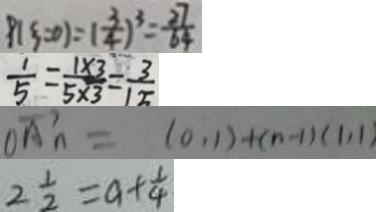<formula> <loc_0><loc_0><loc_500><loc_500>p ( \xi = 0 ) = ( \frac { 3 } { 4 } ) ^ { 3 } = \frac { 2 7 } { 6 4 } 
 \frac { 1 } { 5 } = \frac { 1 \times 3 } { 5 \times 3 } = \frac { 3 } { 1 5 } 
 \xrightarrow [ o A n ] = ( 0 , 1 ) + ( n - 1 ) ( 1 , 1 ) 
 2 \frac { 1 } { 2 } = a + \frac { 1 } { 4 }</formula> 